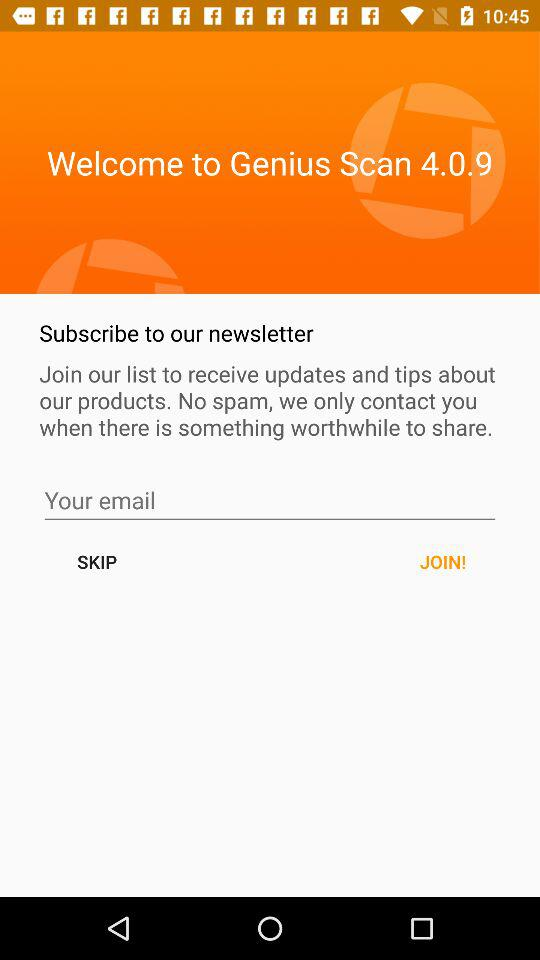What is the application name? The application is "Welcome to Genius Scan 4.0.9". 